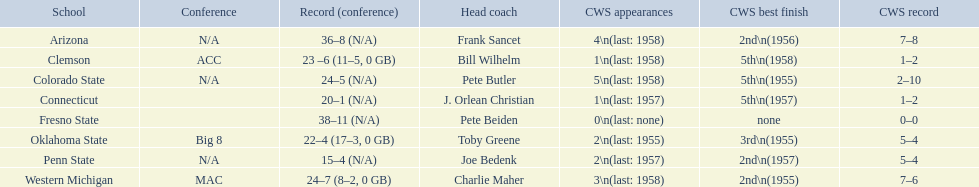What were the results for each school in the 1959 ncaa tournament? 36–8 (N/A), 23 –6 (11–5, 0 GB), 24–5 (N/A), 20–1 (N/A), 38–11 (N/A), 22–4 (17–3, 0 GB), 15–4 (N/A), 24–7 (8–2, 0 GB). Which score did not have a minimum of 16 victories? 15–4 (N/A). Which team achieved this score? Penn State. 